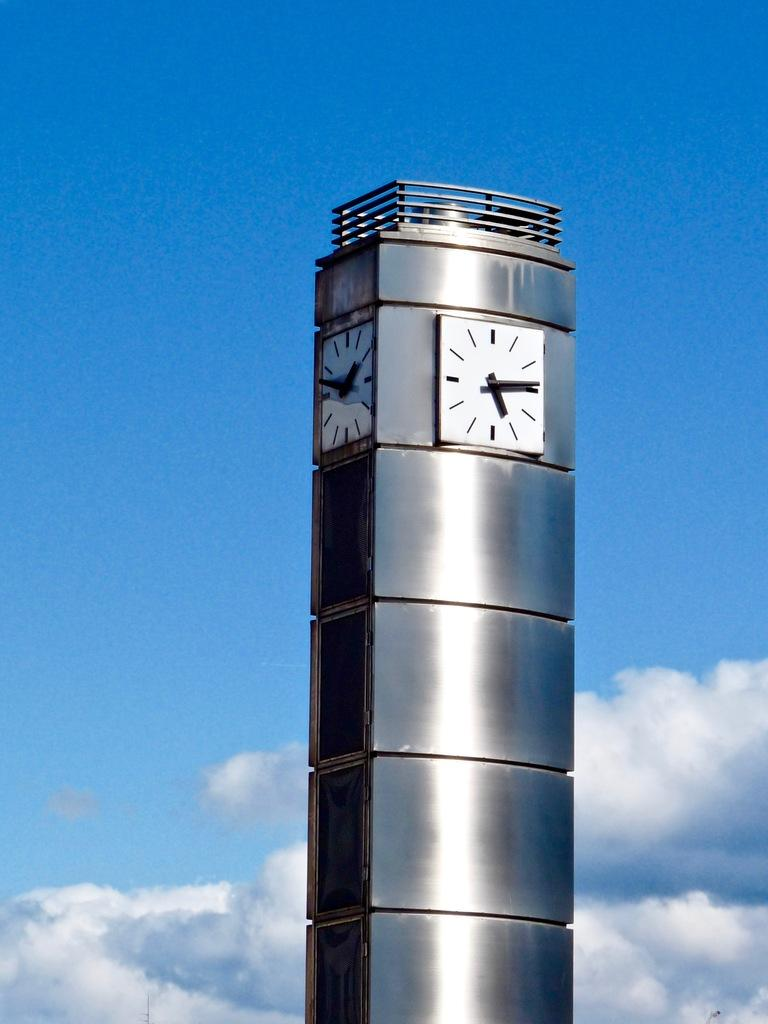What is the main structure in the center of the image? There is a clock tower in the center of the image. What can be seen in the sky in the background of the image? There are clouds in the sky in the background of the image. Where is the pig located in the image? There is no pig present in the image. What type of bottle can be seen on the clock tower? There is no bottle present on the clock tower in the image. 